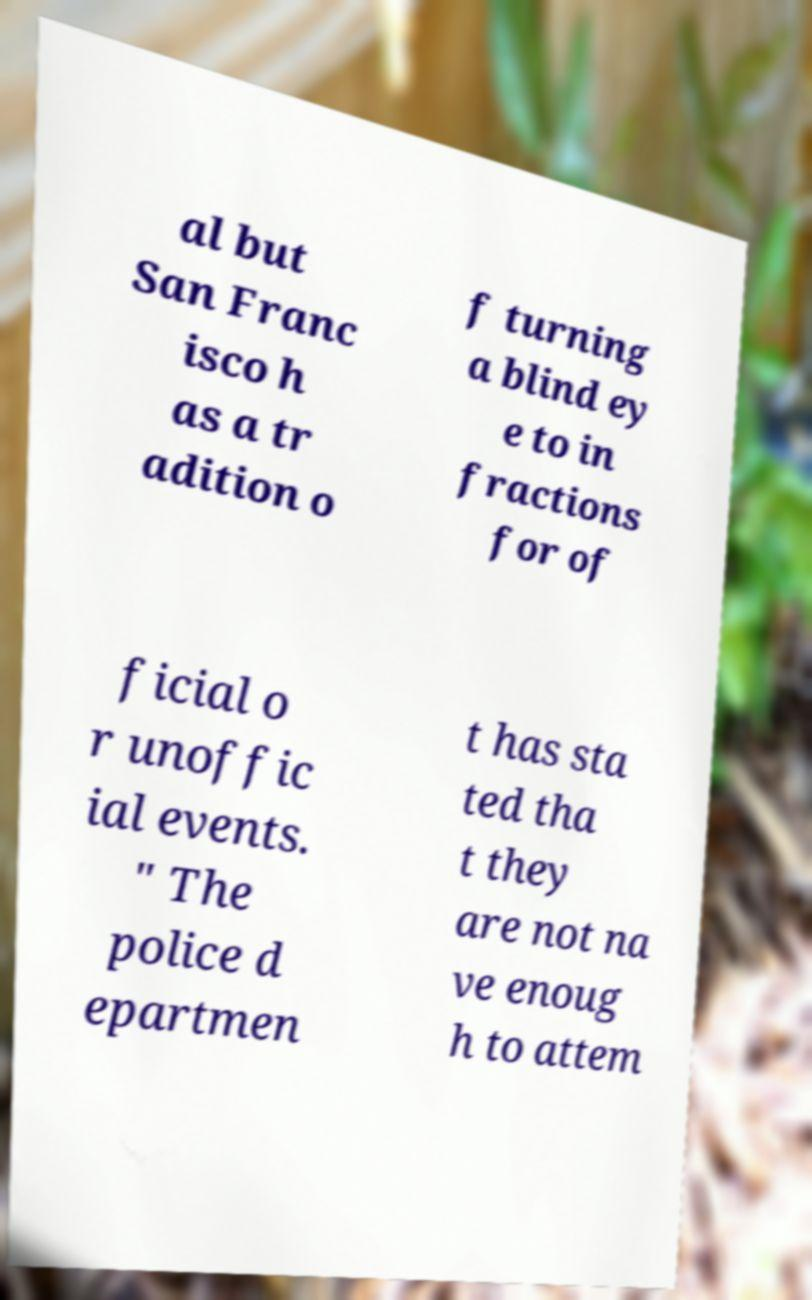Please identify and transcribe the text found in this image. al but San Franc isco h as a tr adition o f turning a blind ey e to in fractions for of ficial o r unoffic ial events. " The police d epartmen t has sta ted tha t they are not na ve enoug h to attem 